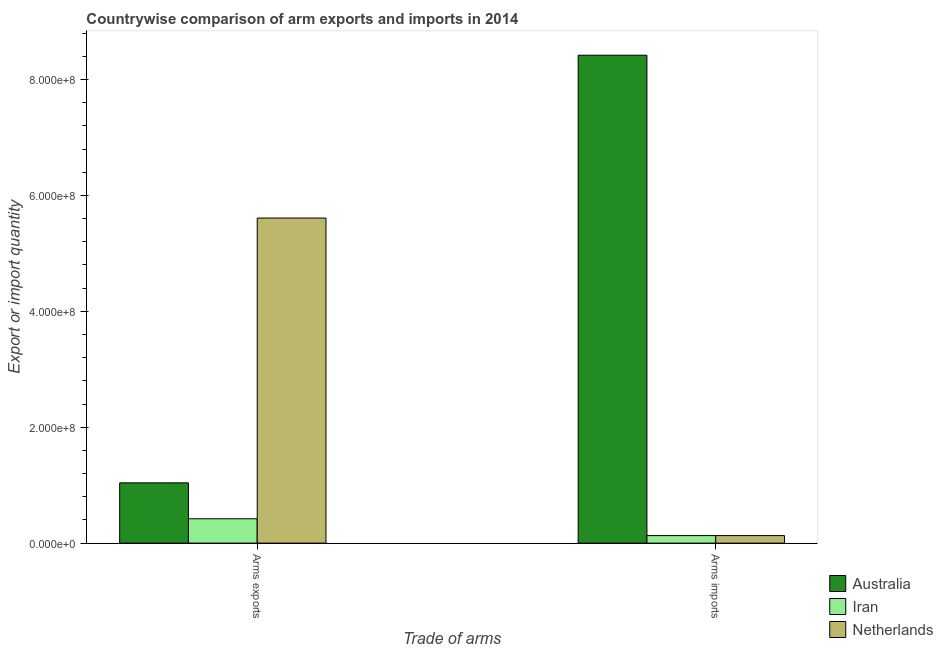How many different coloured bars are there?
Your answer should be very brief. 3. How many groups of bars are there?
Ensure brevity in your answer.  2. Are the number of bars on each tick of the X-axis equal?
Offer a very short reply. Yes. How many bars are there on the 2nd tick from the right?
Make the answer very short. 3. What is the label of the 2nd group of bars from the left?
Your answer should be very brief. Arms imports. What is the arms exports in Australia?
Your answer should be very brief. 1.04e+08. Across all countries, what is the maximum arms exports?
Your answer should be compact. 5.61e+08. Across all countries, what is the minimum arms imports?
Keep it short and to the point. 1.30e+07. In which country was the arms exports minimum?
Offer a terse response. Iran. What is the total arms exports in the graph?
Your answer should be compact. 7.07e+08. What is the difference between the arms imports in Netherlands and that in Australia?
Offer a very short reply. -8.29e+08. What is the difference between the arms exports in Australia and the arms imports in Iran?
Your answer should be very brief. 9.10e+07. What is the average arms exports per country?
Your answer should be very brief. 2.36e+08. What is the difference between the arms exports and arms imports in Iran?
Ensure brevity in your answer.  2.90e+07. In how many countries, is the arms exports greater than 600000000 ?
Offer a very short reply. 0. What is the ratio of the arms exports in Iran to that in Australia?
Your answer should be very brief. 0.4. What does the 3rd bar from the left in Arms exports represents?
Give a very brief answer. Netherlands. What does the 3rd bar from the right in Arms exports represents?
Make the answer very short. Australia. Are all the bars in the graph horizontal?
Give a very brief answer. No. Are the values on the major ticks of Y-axis written in scientific E-notation?
Give a very brief answer. Yes. How are the legend labels stacked?
Keep it short and to the point. Vertical. What is the title of the graph?
Make the answer very short. Countrywise comparison of arm exports and imports in 2014. Does "Faeroe Islands" appear as one of the legend labels in the graph?
Make the answer very short. No. What is the label or title of the X-axis?
Your answer should be compact. Trade of arms. What is the label or title of the Y-axis?
Make the answer very short. Export or import quantity. What is the Export or import quantity in Australia in Arms exports?
Make the answer very short. 1.04e+08. What is the Export or import quantity of Iran in Arms exports?
Make the answer very short. 4.20e+07. What is the Export or import quantity in Netherlands in Arms exports?
Give a very brief answer. 5.61e+08. What is the Export or import quantity in Australia in Arms imports?
Your answer should be compact. 8.42e+08. What is the Export or import quantity in Iran in Arms imports?
Keep it short and to the point. 1.30e+07. What is the Export or import quantity in Netherlands in Arms imports?
Provide a short and direct response. 1.30e+07. Across all Trade of arms, what is the maximum Export or import quantity of Australia?
Your answer should be compact. 8.42e+08. Across all Trade of arms, what is the maximum Export or import quantity in Iran?
Your response must be concise. 4.20e+07. Across all Trade of arms, what is the maximum Export or import quantity in Netherlands?
Make the answer very short. 5.61e+08. Across all Trade of arms, what is the minimum Export or import quantity of Australia?
Provide a succinct answer. 1.04e+08. Across all Trade of arms, what is the minimum Export or import quantity of Iran?
Provide a short and direct response. 1.30e+07. Across all Trade of arms, what is the minimum Export or import quantity in Netherlands?
Provide a succinct answer. 1.30e+07. What is the total Export or import quantity in Australia in the graph?
Your answer should be very brief. 9.46e+08. What is the total Export or import quantity of Iran in the graph?
Give a very brief answer. 5.50e+07. What is the total Export or import quantity of Netherlands in the graph?
Your response must be concise. 5.74e+08. What is the difference between the Export or import quantity of Australia in Arms exports and that in Arms imports?
Make the answer very short. -7.38e+08. What is the difference between the Export or import quantity in Iran in Arms exports and that in Arms imports?
Make the answer very short. 2.90e+07. What is the difference between the Export or import quantity in Netherlands in Arms exports and that in Arms imports?
Make the answer very short. 5.48e+08. What is the difference between the Export or import quantity in Australia in Arms exports and the Export or import quantity in Iran in Arms imports?
Ensure brevity in your answer.  9.10e+07. What is the difference between the Export or import quantity of Australia in Arms exports and the Export or import quantity of Netherlands in Arms imports?
Give a very brief answer. 9.10e+07. What is the difference between the Export or import quantity of Iran in Arms exports and the Export or import quantity of Netherlands in Arms imports?
Ensure brevity in your answer.  2.90e+07. What is the average Export or import quantity in Australia per Trade of arms?
Provide a succinct answer. 4.73e+08. What is the average Export or import quantity of Iran per Trade of arms?
Offer a very short reply. 2.75e+07. What is the average Export or import quantity of Netherlands per Trade of arms?
Ensure brevity in your answer.  2.87e+08. What is the difference between the Export or import quantity in Australia and Export or import quantity in Iran in Arms exports?
Provide a short and direct response. 6.20e+07. What is the difference between the Export or import quantity in Australia and Export or import quantity in Netherlands in Arms exports?
Your response must be concise. -4.57e+08. What is the difference between the Export or import quantity of Iran and Export or import quantity of Netherlands in Arms exports?
Keep it short and to the point. -5.19e+08. What is the difference between the Export or import quantity in Australia and Export or import quantity in Iran in Arms imports?
Your response must be concise. 8.29e+08. What is the difference between the Export or import quantity in Australia and Export or import quantity in Netherlands in Arms imports?
Ensure brevity in your answer.  8.29e+08. What is the ratio of the Export or import quantity in Australia in Arms exports to that in Arms imports?
Offer a very short reply. 0.12. What is the ratio of the Export or import quantity of Iran in Arms exports to that in Arms imports?
Ensure brevity in your answer.  3.23. What is the ratio of the Export or import quantity in Netherlands in Arms exports to that in Arms imports?
Offer a terse response. 43.15. What is the difference between the highest and the second highest Export or import quantity in Australia?
Your response must be concise. 7.38e+08. What is the difference between the highest and the second highest Export or import quantity of Iran?
Offer a terse response. 2.90e+07. What is the difference between the highest and the second highest Export or import quantity in Netherlands?
Provide a succinct answer. 5.48e+08. What is the difference between the highest and the lowest Export or import quantity in Australia?
Offer a terse response. 7.38e+08. What is the difference between the highest and the lowest Export or import quantity in Iran?
Keep it short and to the point. 2.90e+07. What is the difference between the highest and the lowest Export or import quantity of Netherlands?
Your response must be concise. 5.48e+08. 